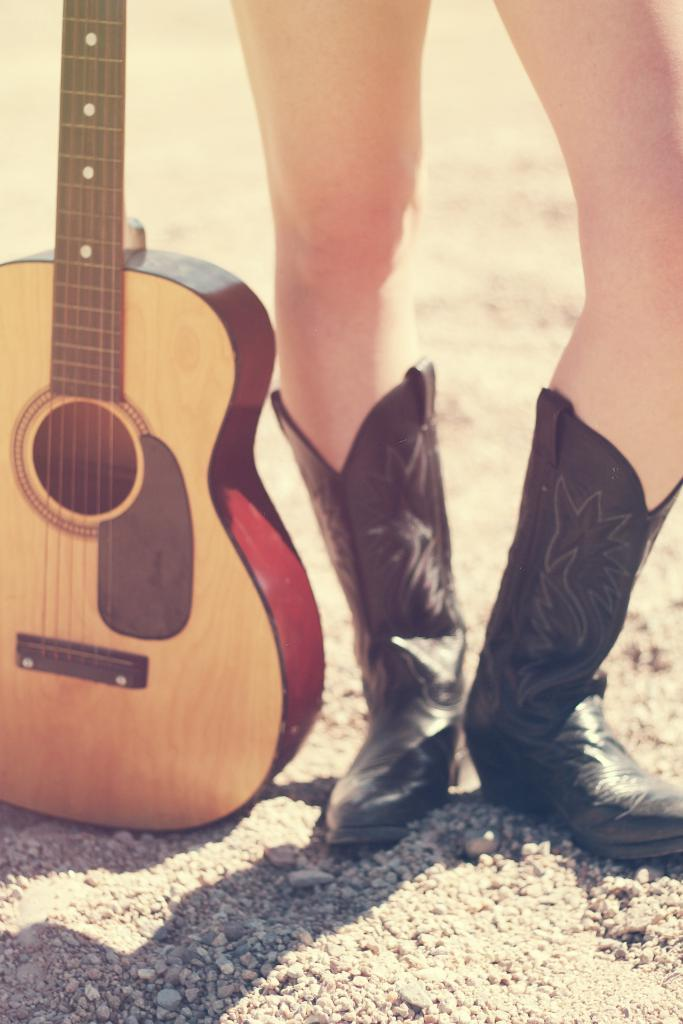What is the main subject of the image? There is a person in the image. What is the person doing in the image? The person is standing. What type of footwear is the person wearing? The person is wearing black boots. What object is beside the person? There is a guitar beside the person. How many birds are in the flock that is flying over the person in the image? There are no birds or flocks present in the image. What type of engine is powering the guitar in the image? There is no engine present in the image; it is a guitar, which is a musical instrument. 